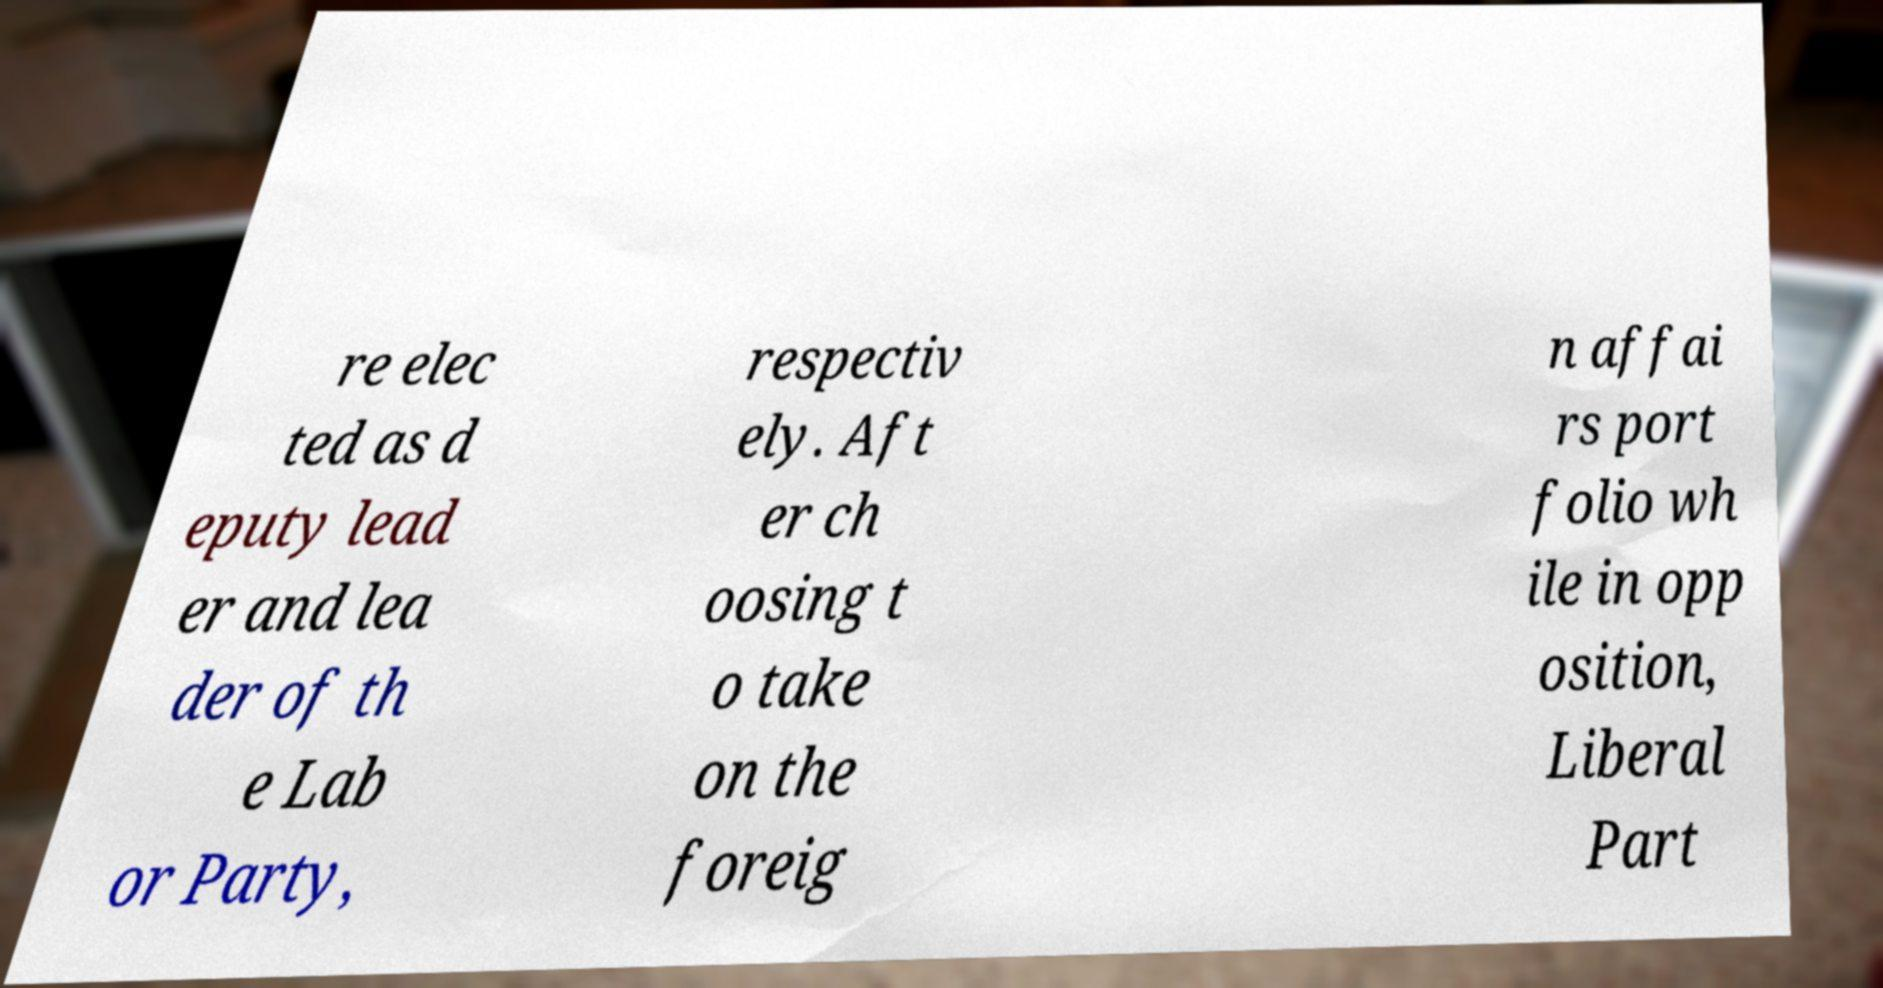Can you read and provide the text displayed in the image?This photo seems to have some interesting text. Can you extract and type it out for me? re elec ted as d eputy lead er and lea der of th e Lab or Party, respectiv ely. Aft er ch oosing t o take on the foreig n affai rs port folio wh ile in opp osition, Liberal Part 